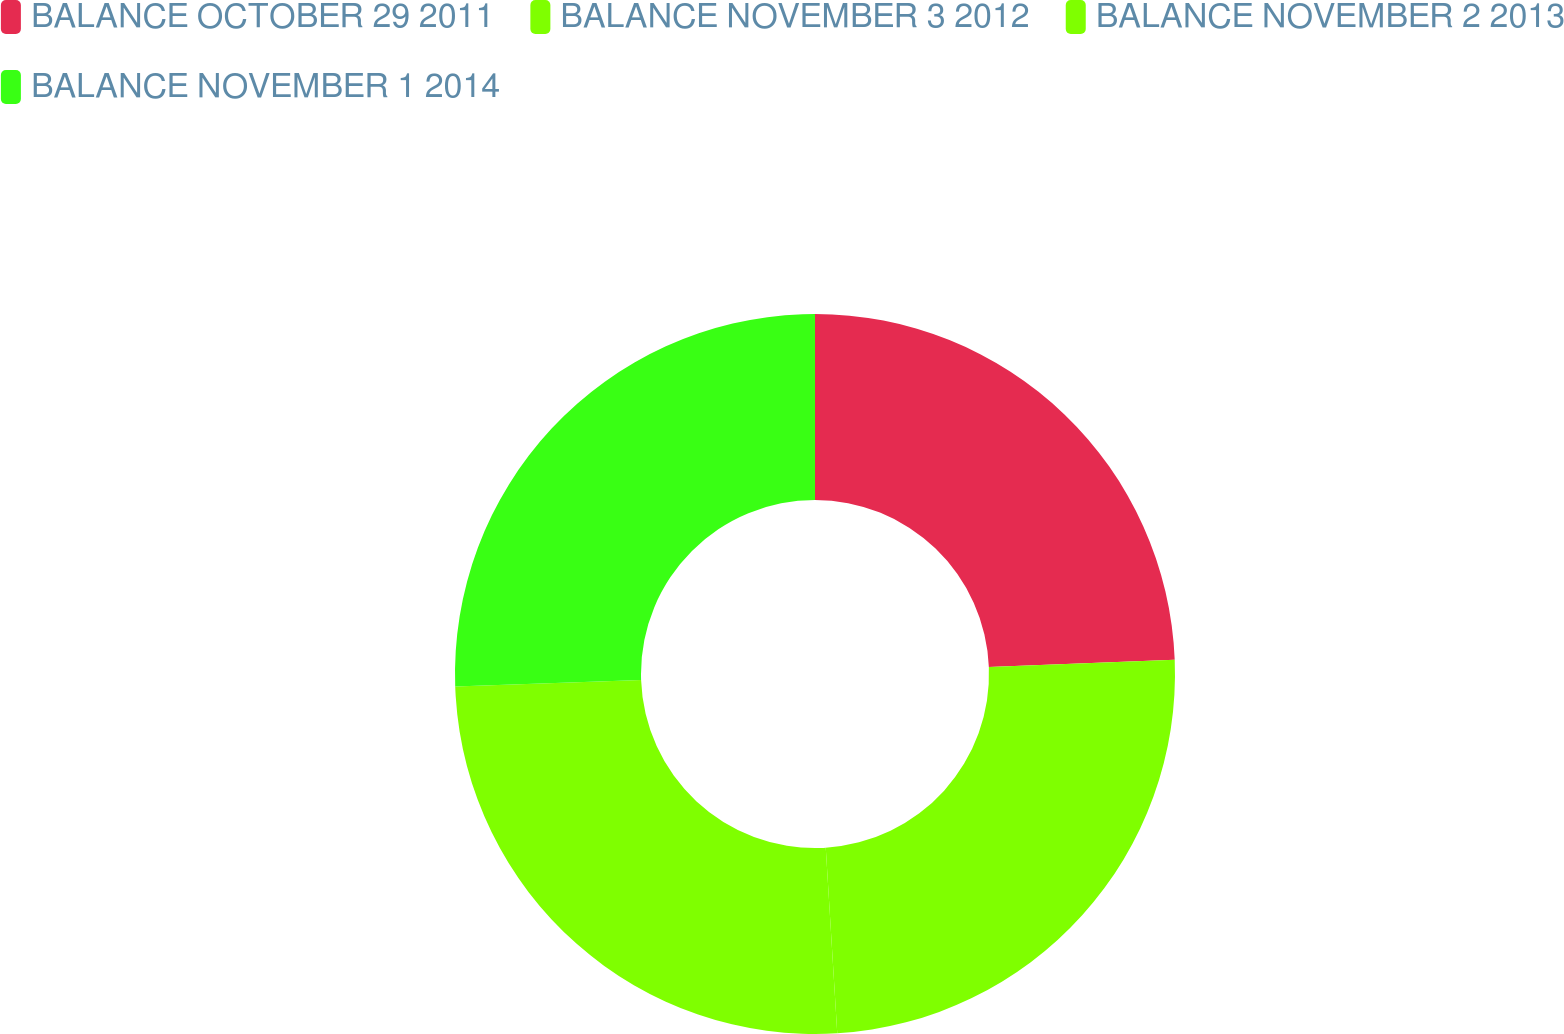<chart> <loc_0><loc_0><loc_500><loc_500><pie_chart><fcel>BALANCE OCTOBER 29 2011<fcel>BALANCE NOVEMBER 3 2012<fcel>BALANCE NOVEMBER 2 2013<fcel>BALANCE NOVEMBER 1 2014<nl><fcel>24.37%<fcel>24.65%<fcel>25.44%<fcel>25.55%<nl></chart> 